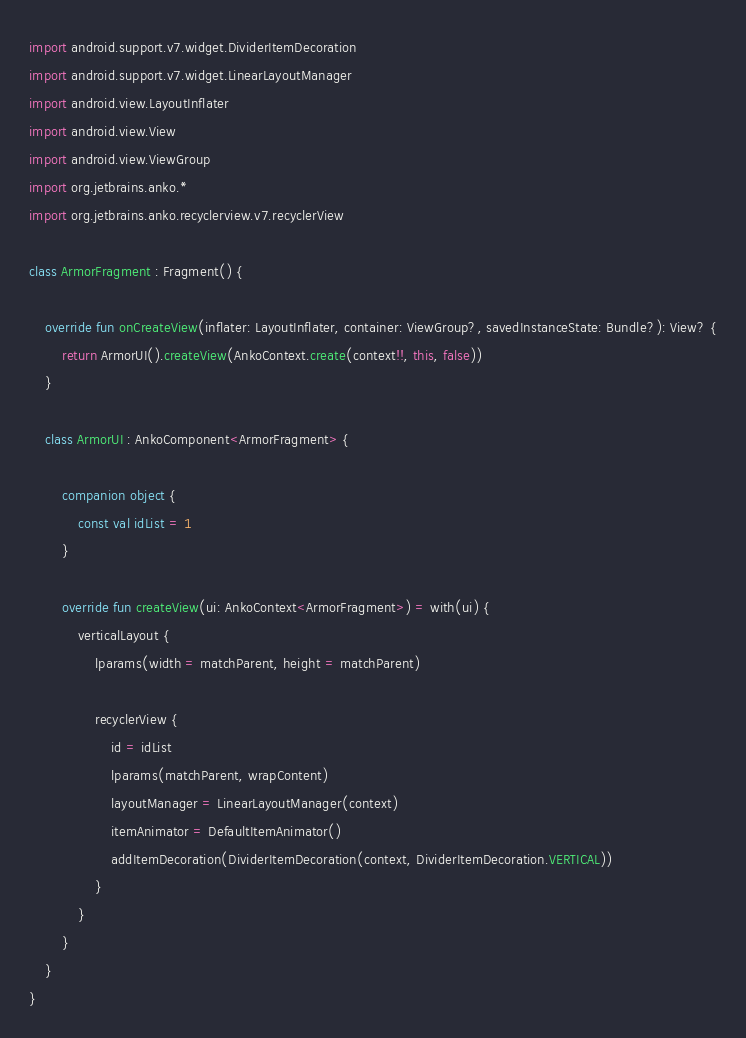<code> <loc_0><loc_0><loc_500><loc_500><_Kotlin_>import android.support.v7.widget.DividerItemDecoration
import android.support.v7.widget.LinearLayoutManager
import android.view.LayoutInflater
import android.view.View
import android.view.ViewGroup
import org.jetbrains.anko.*
import org.jetbrains.anko.recyclerview.v7.recyclerView

class ArmorFragment : Fragment() {

    override fun onCreateView(inflater: LayoutInflater, container: ViewGroup?, savedInstanceState: Bundle?): View? {
        return ArmorUI().createView(AnkoContext.create(context!!, this, false))
    }

    class ArmorUI : AnkoComponent<ArmorFragment> {

        companion object {
            const val idList = 1
        }

        override fun createView(ui: AnkoContext<ArmorFragment>) = with(ui) {
            verticalLayout {
                lparams(width = matchParent, height = matchParent)

                recyclerView {
                    id = idList
                    lparams(matchParent, wrapContent)
                    layoutManager = LinearLayoutManager(context)
                    itemAnimator = DefaultItemAnimator()
                    addItemDecoration(DividerItemDecoration(context, DividerItemDecoration.VERTICAL))
                }
            }
        }
    }
}</code> 